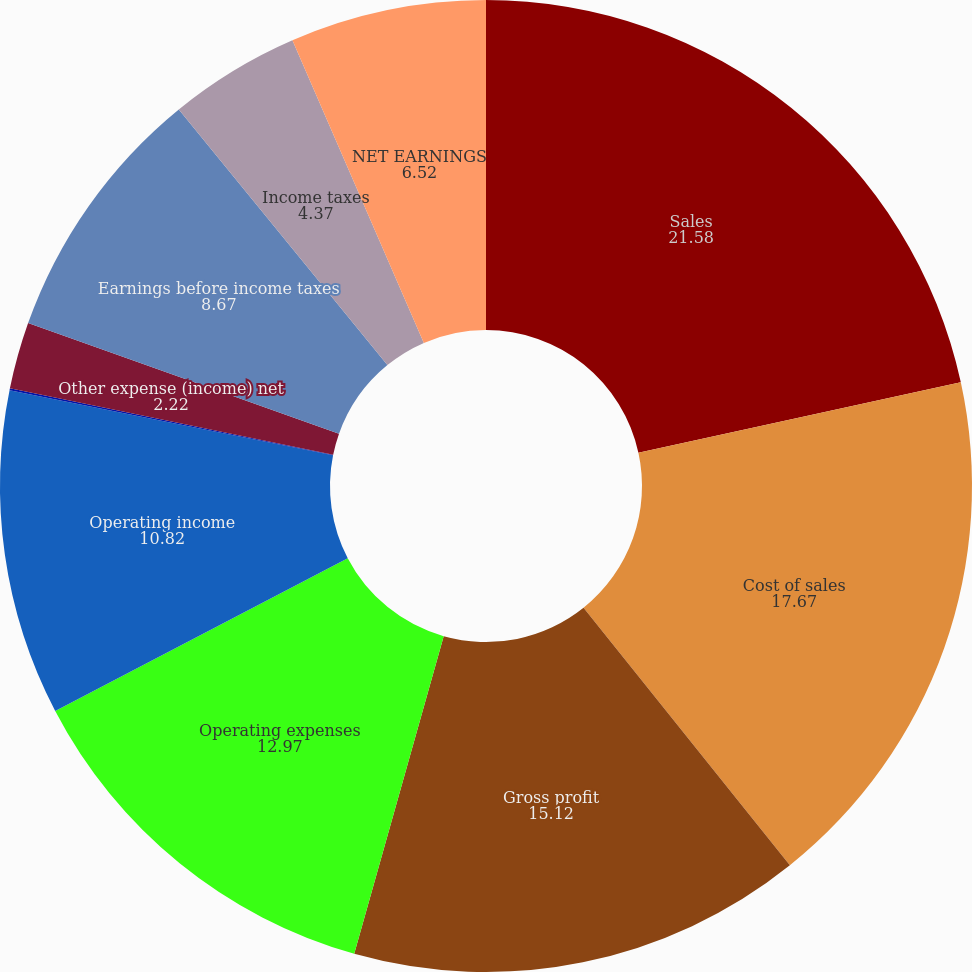Convert chart. <chart><loc_0><loc_0><loc_500><loc_500><pie_chart><fcel>Sales<fcel>Cost of sales<fcel>Gross profit<fcel>Operating expenses<fcel>Operating income<fcel>Interest expense<fcel>Other expense (income) net<fcel>Earnings before income taxes<fcel>Income taxes<fcel>NET EARNINGS<nl><fcel>21.58%<fcel>17.67%<fcel>15.12%<fcel>12.97%<fcel>10.82%<fcel>0.06%<fcel>2.22%<fcel>8.67%<fcel>4.37%<fcel>6.52%<nl></chart> 